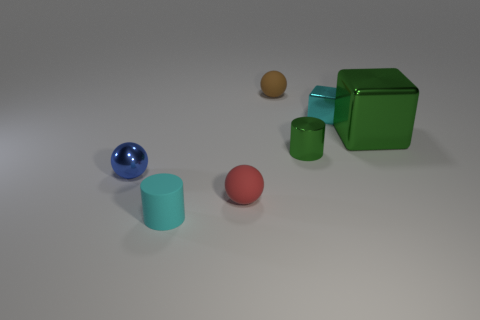Subtract all blue metal balls. How many balls are left? 2 Add 2 green metallic objects. How many objects exist? 9 Subtract all cylinders. How many objects are left? 5 Subtract 1 spheres. How many spheres are left? 2 Subtract all green spheres. Subtract all purple cylinders. How many spheres are left? 3 Add 1 green metal cylinders. How many green metal cylinders exist? 2 Subtract 0 green spheres. How many objects are left? 7 Subtract all green things. Subtract all small metal blocks. How many objects are left? 4 Add 5 cyan rubber things. How many cyan rubber things are left? 6 